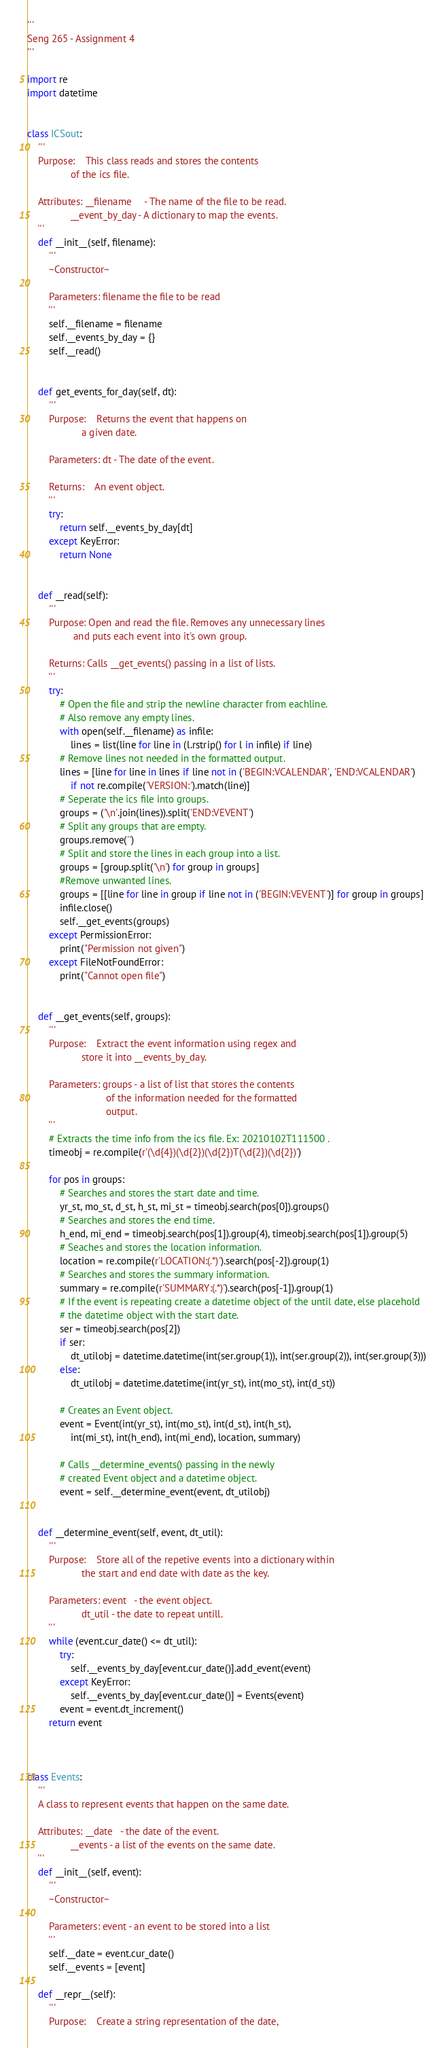Convert code to text. <code><loc_0><loc_0><loc_500><loc_500><_Python_>'''
Seng 265 - Assignment 4
'''

import re
import datetime


class ICSout:
    '''
    Purpose:    This class reads and stores the contents 
                of the ics file.

    Attributes: __filename     - The name of the file to be read. 
                __event_by_day - A dictionary to map the events.
    ''' 
    def __init__(self, filename):
        '''
        ~Constructor~

        Parameters: filename the file to be read
        '''
        self.__filename = filename
        self.__events_by_day = {}
        self.__read()

    
    def get_events_for_day(self, dt):
        '''
        Purpose:    Returns the event that happens on
                    a given date. 

        Parameters: dt - The date of the event.
    
        Returns:    An event object.
        '''
        try:
            return self.__events_by_day[dt]
        except KeyError:
            return None

    
    def __read(self):
        '''
        Purpose: Open and read the file. Removes any unnecessary lines 
                 and puts each event into it's own group.

        Returns: Calls __get_events() passing in a list of lists.
        '''
        try:          
            # Open the file and strip the newline character from eachline. 
            # Also remove any empty lines.
            with open(self.__filename) as infile: 
                lines = list(line for line in (l.rstrip() for l in infile) if line)    
            # Remove lines not needed in the formatted output.    
            lines = [line for line in lines if line not in ('BEGIN:VCALENDAR', 'END:VCALENDAR') 
                if not re.compile('VERSION:').match(line)]
            # Seperate the ics file into groups.
            groups = ('\n'.join(lines)).split('END:VEVENT')
            # Split any groups that are empty. 
            groups.remove('')
            # Split and store the lines in each group into a list.                                     
            groups = [group.split('\n') for group in groups]
            #Remove unwanted lines.  
            groups = [[line for line in group if line not in ('BEGIN:VEVENT')] for group in groups]
            infile.close()
            self.__get_events(groups)
        except PermissionError:
            print("Permission not given")
        except FileNotFoundError:
            print("Cannot open file")
 

    def __get_events(self, groups):
        '''
        Purpose:    Extract the event information using regex and
                    store it into __events_by_day.

        Parameters: groups - a list of list that stores the contents 
                             of the information needed for the formatted
                             output.
        '''
        # Extracts the time info from the ics file. Ex: 20210102T111500 .
        timeobj = re.compile(r'(\d{4})(\d{2})(\d{2})T(\d{2})(\d{2})')

        for pos in groups:
            # Searches and stores the start date and time.
            yr_st, mo_st, d_st, h_st, mi_st = timeobj.search(pos[0]).groups()
            # Searches and stores the end time.
            h_end, mi_end = timeobj.search(pos[1]).group(4), timeobj.search(pos[1]).group(5)
            # Seaches and stores the location information.          
            location = re.compile(r'LOCATION:(.*)').search(pos[-2]).group(1)
            # Searches and stores the summary information.
            summary = re.compile(r'SUMMARY:(.*)').search(pos[-1]).group(1)
            # If the event is repeating create a datetime object of the until date, else placehold 
            # the datetime object with the start date.
            ser = timeobj.search(pos[2])
            if ser:
                dt_utilobj = datetime.datetime(int(ser.group(1)), int(ser.group(2)), int(ser.group(3)))
            else:
                dt_utilobj = datetime.datetime(int(yr_st), int(mo_st), int(d_st))

            # Creates an Event object.
            event = Event(int(yr_st), int(mo_st), int(d_st), int(h_st),
                int(mi_st), int(h_end), int(mi_end), location, summary)

            # Calls __determine_events() passing in the newly 
            # created Event object and a datetime object.
            event = self.__determine_event(event, dt_utilobj)


    def __determine_event(self, event, dt_util):
        '''
        Purpose:    Store all of the repetive events into a dictionary within 
                    the start and end date with date as the key.

        Parameters: event   - the event object.
                    dt_util - the date to repeat untill. 
        '''
        while (event.cur_date() <= dt_util):       
            try:
                self.__events_by_day[event.cur_date()].add_event(event)
            except KeyError:
                self.__events_by_day[event.cur_date()] = Events(event)
            event = event.dt_increment()
        return event



class Events:
    '''
    A class to represent events that happen on the same date.

    Attributes: __date   - the date of the event.
                __events - a list of the events on the same date.
    '''
    def __init__(self, event):
        '''
        ~Constructor~        

        Parameters: event - an event to be stored into a list      
        '''
        self.__date = event.cur_date()
        self.__events = [event]

    def __repr__(self):
        '''
        Purpose:    Create a string representation of the date, </code> 